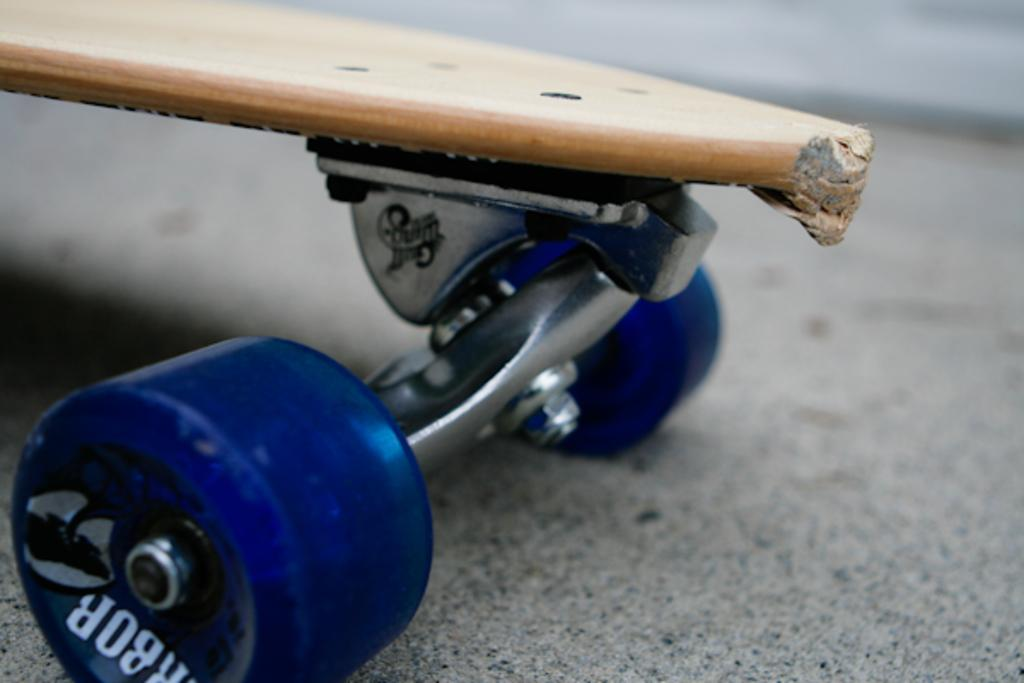What object is the main focus of the image? There is a skateboard in the image. What type of whistle can be seen attached to the skateboard in the image? There is no whistle present on the skateboard in the image. What is the emotional state of the skateboard in the image, as indicated by its heart rate? Skateboards do not have emotions or heart rates, so this question cannot be answered. 